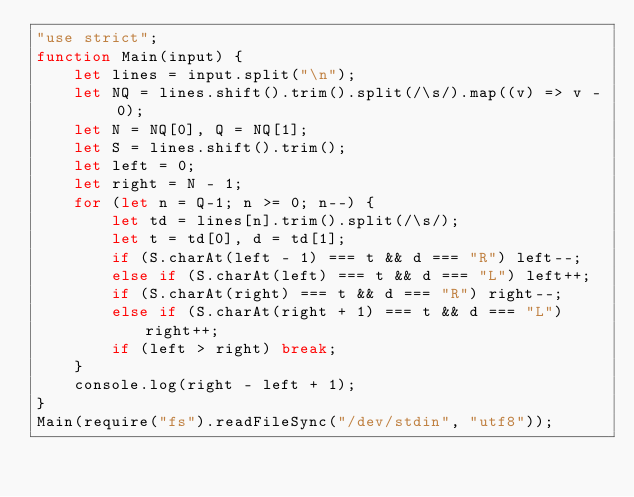Convert code to text. <code><loc_0><loc_0><loc_500><loc_500><_JavaScript_>"use strict";
function Main(input) {
    let lines = input.split("\n");
    let NQ = lines.shift().trim().split(/\s/).map((v) => v - 0);
    let N = NQ[0], Q = NQ[1];
    let S = lines.shift().trim();
    let left = 0;
    let right = N - 1;
    for (let n = Q-1; n >= 0; n--) {
        let td = lines[n].trim().split(/\s/);
        let t = td[0], d = td[1];
        if (S.charAt(left - 1) === t && d === "R") left--;
        else if (S.charAt(left) === t && d === "L") left++;
        if (S.charAt(right) === t && d === "R") right--;
        else if (S.charAt(right + 1) === t && d === "L") right++;
        if (left > right) break;
    }
    console.log(right - left + 1);
}
Main(require("fs").readFileSync("/dev/stdin", "utf8"));</code> 